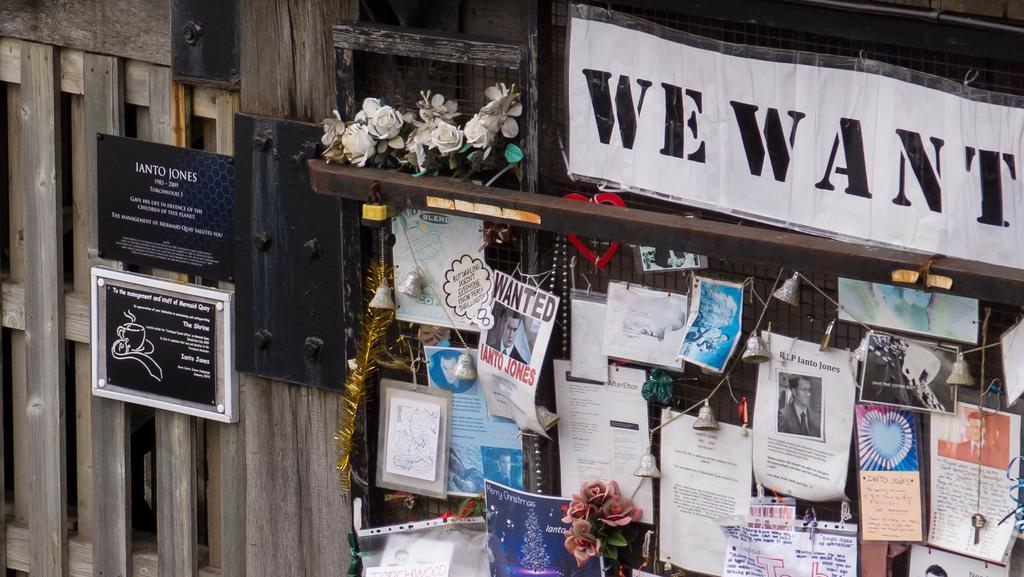Could you give a brief overview of what you see in this image? In the center of the image there is a fence and we can see papers, decors, flowers and boards placed on the fence. 